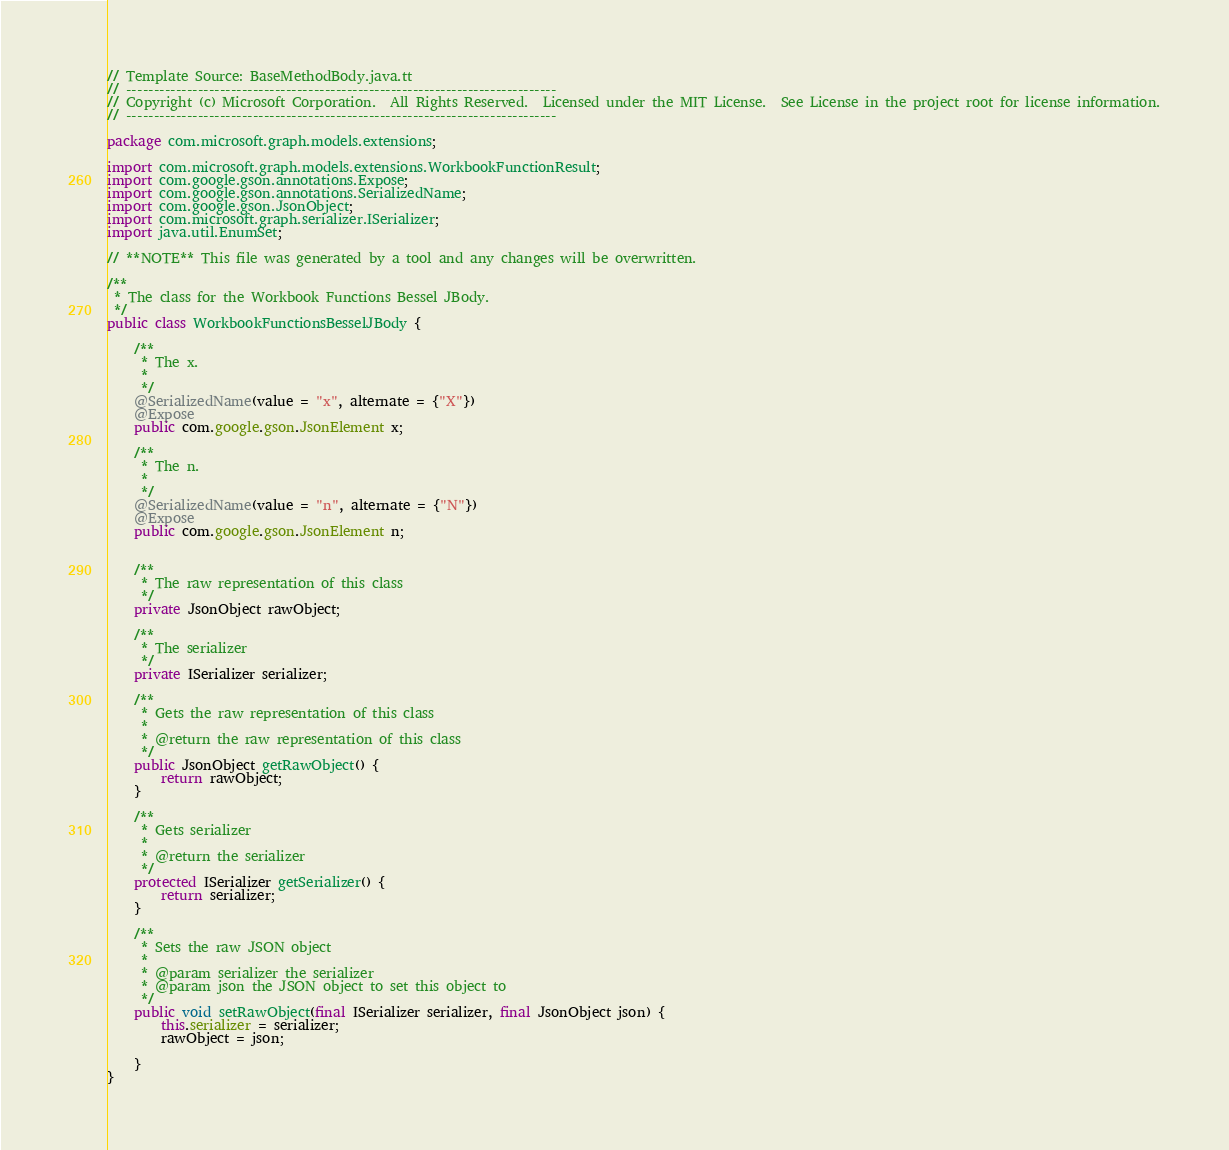Convert code to text. <code><loc_0><loc_0><loc_500><loc_500><_Java_>// Template Source: BaseMethodBody.java.tt
// ------------------------------------------------------------------------------
// Copyright (c) Microsoft Corporation.  All Rights Reserved.  Licensed under the MIT License.  See License in the project root for license information.
// ------------------------------------------------------------------------------

package com.microsoft.graph.models.extensions;

import com.microsoft.graph.models.extensions.WorkbookFunctionResult;
import com.google.gson.annotations.Expose;
import com.google.gson.annotations.SerializedName;
import com.google.gson.JsonObject;
import com.microsoft.graph.serializer.ISerializer;
import java.util.EnumSet;

// **NOTE** This file was generated by a tool and any changes will be overwritten.

/**
 * The class for the Workbook Functions Bessel JBody.
 */
public class WorkbookFunctionsBesselJBody {

    /**
     * The x.
     * 
     */
    @SerializedName(value = "x", alternate = {"X"})
    @Expose
    public com.google.gson.JsonElement x;

    /**
     * The n.
     * 
     */
    @SerializedName(value = "n", alternate = {"N"})
    @Expose
    public com.google.gson.JsonElement n;


    /**
     * The raw representation of this class
     */
    private JsonObject rawObject;

    /**
     * The serializer
     */
    private ISerializer serializer;

    /**
     * Gets the raw representation of this class
     *
     * @return the raw representation of this class
     */
    public JsonObject getRawObject() {
        return rawObject;
    }

    /**
     * Gets serializer
     *
     * @return the serializer
     */
    protected ISerializer getSerializer() {
        return serializer;
    }

    /**
     * Sets the raw JSON object
     *
     * @param serializer the serializer
     * @param json the JSON object to set this object to
     */
    public void setRawObject(final ISerializer serializer, final JsonObject json) {
        this.serializer = serializer;
        rawObject = json;

    }
}
</code> 